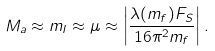Convert formula to latex. <formula><loc_0><loc_0><loc_500><loc_500>M _ { a } \approx m _ { I } \approx \mu \approx \left | \frac { \lambda ( m _ { f } ) F _ { S } } { 1 6 \pi ^ { 2 } m _ { f } } \right | .</formula> 